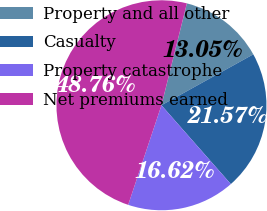Convert chart. <chart><loc_0><loc_0><loc_500><loc_500><pie_chart><fcel>Property and all other<fcel>Casualty<fcel>Property catastrophe<fcel>Net premiums earned<nl><fcel>13.05%<fcel>21.57%<fcel>16.62%<fcel>48.76%<nl></chart> 